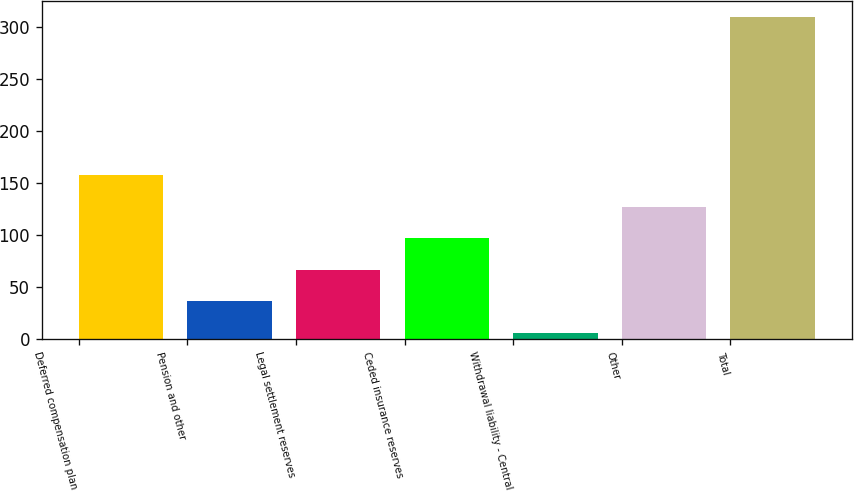<chart> <loc_0><loc_0><loc_500><loc_500><bar_chart><fcel>Deferred compensation plan<fcel>Pension and other<fcel>Legal settlement reserves<fcel>Ceded insurance reserves<fcel>Withdrawal liability - Central<fcel>Other<fcel>Total<nl><fcel>157.7<fcel>36.42<fcel>66.74<fcel>97.06<fcel>6.1<fcel>127.38<fcel>309.3<nl></chart> 